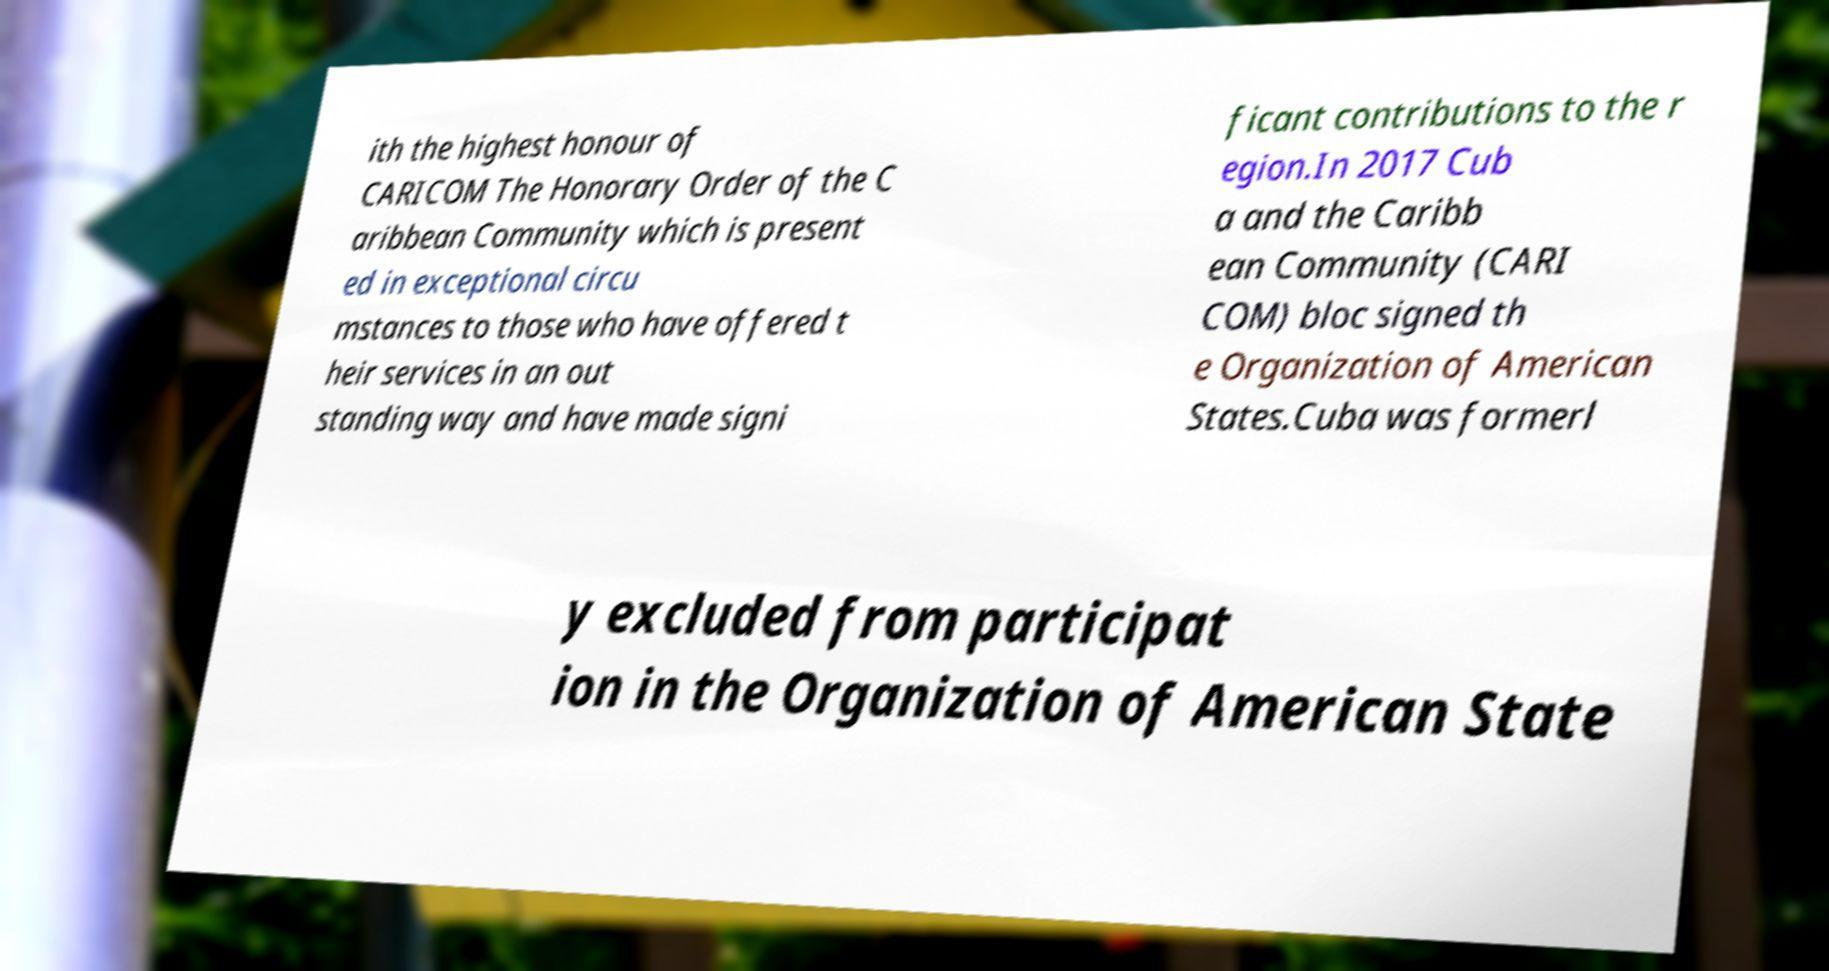There's text embedded in this image that I need extracted. Can you transcribe it verbatim? ith the highest honour of CARICOM The Honorary Order of the C aribbean Community which is present ed in exceptional circu mstances to those who have offered t heir services in an out standing way and have made signi ficant contributions to the r egion.In 2017 Cub a and the Caribb ean Community (CARI COM) bloc signed th e Organization of American States.Cuba was formerl y excluded from participat ion in the Organization of American State 